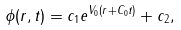Convert formula to latex. <formula><loc_0><loc_0><loc_500><loc_500>\phi ( r , t ) = c _ { 1 } e ^ { V _ { 0 } ( r + C _ { 0 } t ) } + c _ { 2 } ,</formula> 